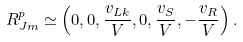Convert formula to latex. <formula><loc_0><loc_0><loc_500><loc_500>R _ { J m } ^ { p } \simeq \left ( 0 , 0 , \frac { v _ { L k } } { V } , 0 , \frac { v _ { S } } { V } , - \frac { v _ { R } } { V } \right ) .</formula> 